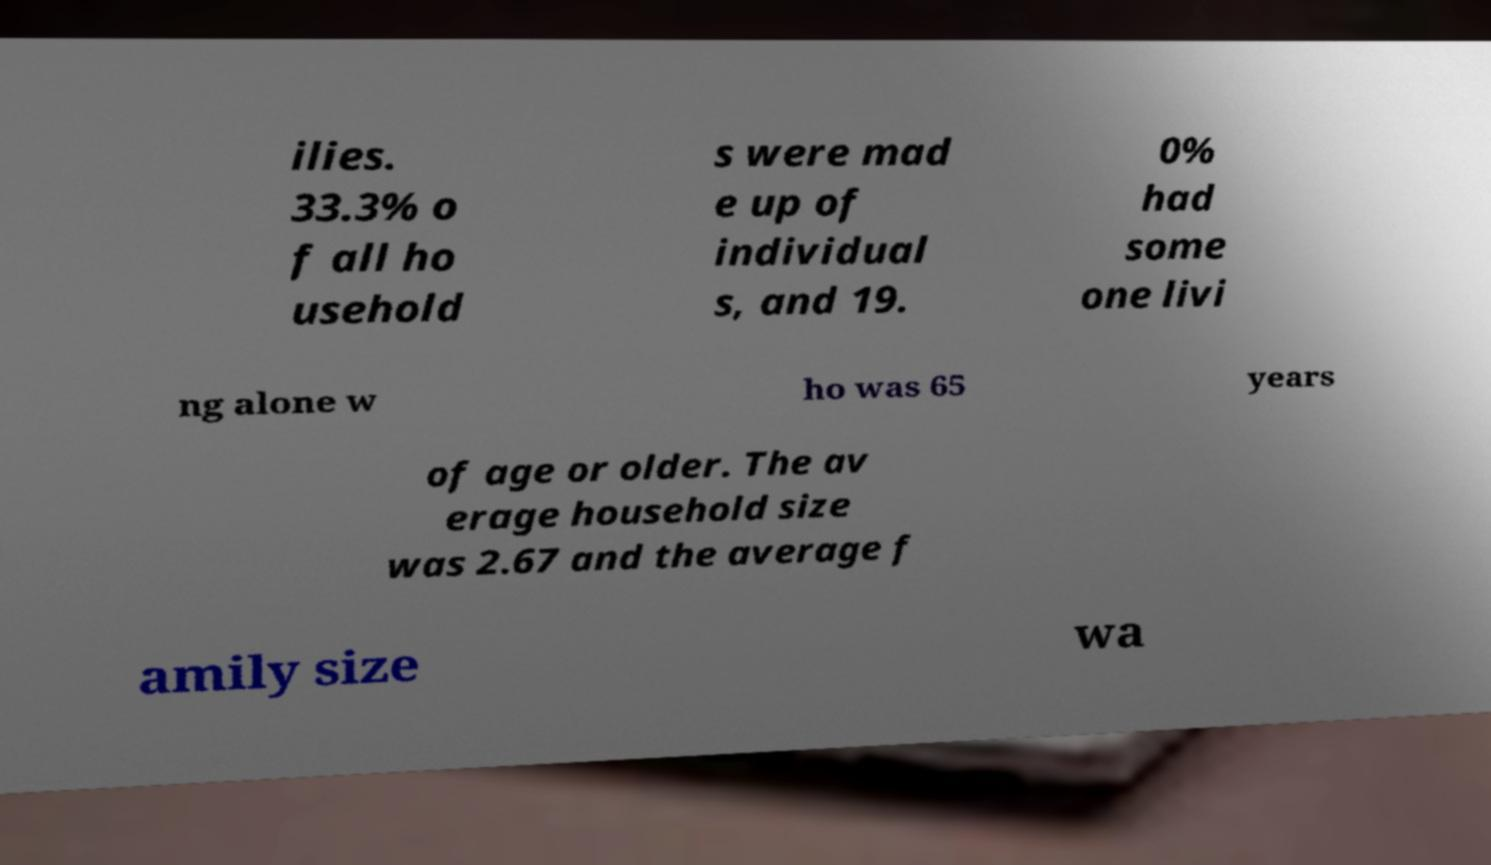There's text embedded in this image that I need extracted. Can you transcribe it verbatim? ilies. 33.3% o f all ho usehold s were mad e up of individual s, and 19. 0% had some one livi ng alone w ho was 65 years of age or older. The av erage household size was 2.67 and the average f amily size wa 